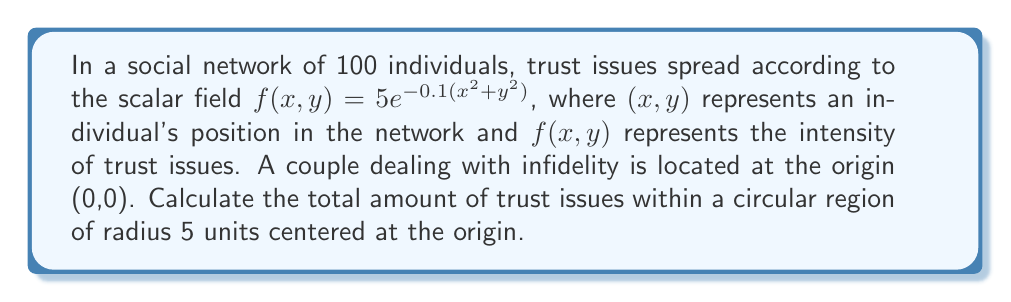Could you help me with this problem? To solve this problem, we need to integrate the scalar field over the given circular region. We'll use polar coordinates for this integration.

Step 1: Convert the scalar field to polar coordinates.
$x = r\cos\theta$, $y = r\sin\theta$
$f(r,\theta) = 5e^{-0.1(r^2\cos^2\theta + r^2\sin^2\theta)} = 5e^{-0.1r^2}$

Step 2: Set up the double integral in polar coordinates.
$$\iint_D f(r,\theta) \, r \, dr \, d\theta$$
where $D$ is the circular region with radius 5.

Step 3: Define the limits of integration.
$0 \leq r \leq 5$ and $0 \leq \theta \leq 2\pi$

Step 4: Evaluate the double integral.
$$\int_0^{2\pi} \int_0^5 5e^{-0.1r^2} \, r \, dr \, d\theta$$

Step 5: Solve the inner integral with respect to $r$.
$$\int_0^{2\pi} \left[-25e^{-0.1r^2}\right]_0^5 \, d\theta$$
$$= \int_0^{2\pi} \left(-25e^{-2.5} + 25\right) \, d\theta$$
$$= \int_0^{2\pi} 25(1 - e^{-2.5}) \, d\theta$$

Step 6: Solve the outer integral with respect to $\theta$.
$$= 25(1 - e^{-2.5}) \cdot 2\pi$$
$$= 50\pi(1 - e^{-2.5})$$

Step 7: Calculate the final result.
$$\approx 153.86$$
Answer: $50\pi(1 - e^{-2.5}) \approx 153.86$ 